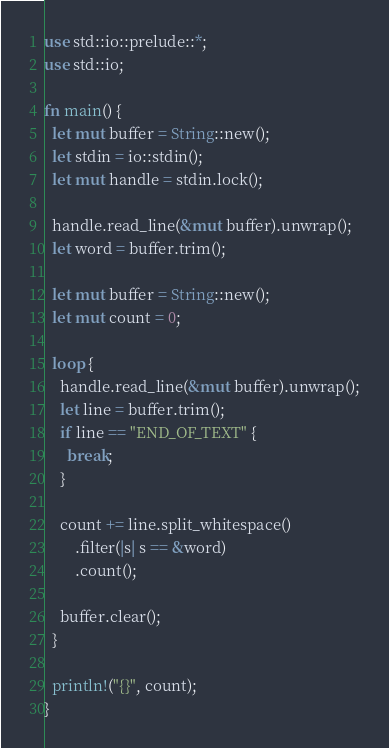<code> <loc_0><loc_0><loc_500><loc_500><_Rust_>use std::io::prelude::*;
use std::io;

fn main() {
  let mut buffer = String::new();
  let stdin = io::stdin();
  let mut handle = stdin.lock();

  handle.read_line(&mut buffer).unwrap();
  let word = buffer.trim();

  let mut buffer = String::new();
  let mut count = 0;
  
  loop {
    handle.read_line(&mut buffer).unwrap();
    let line = buffer.trim();
    if line == "END_OF_TEXT" {
      break;
    }
    
    count += line.split_whitespace()
        .filter(|s| s == &word)
        .count();

    buffer.clear();
  }

  println!("{}", count);
}</code> 